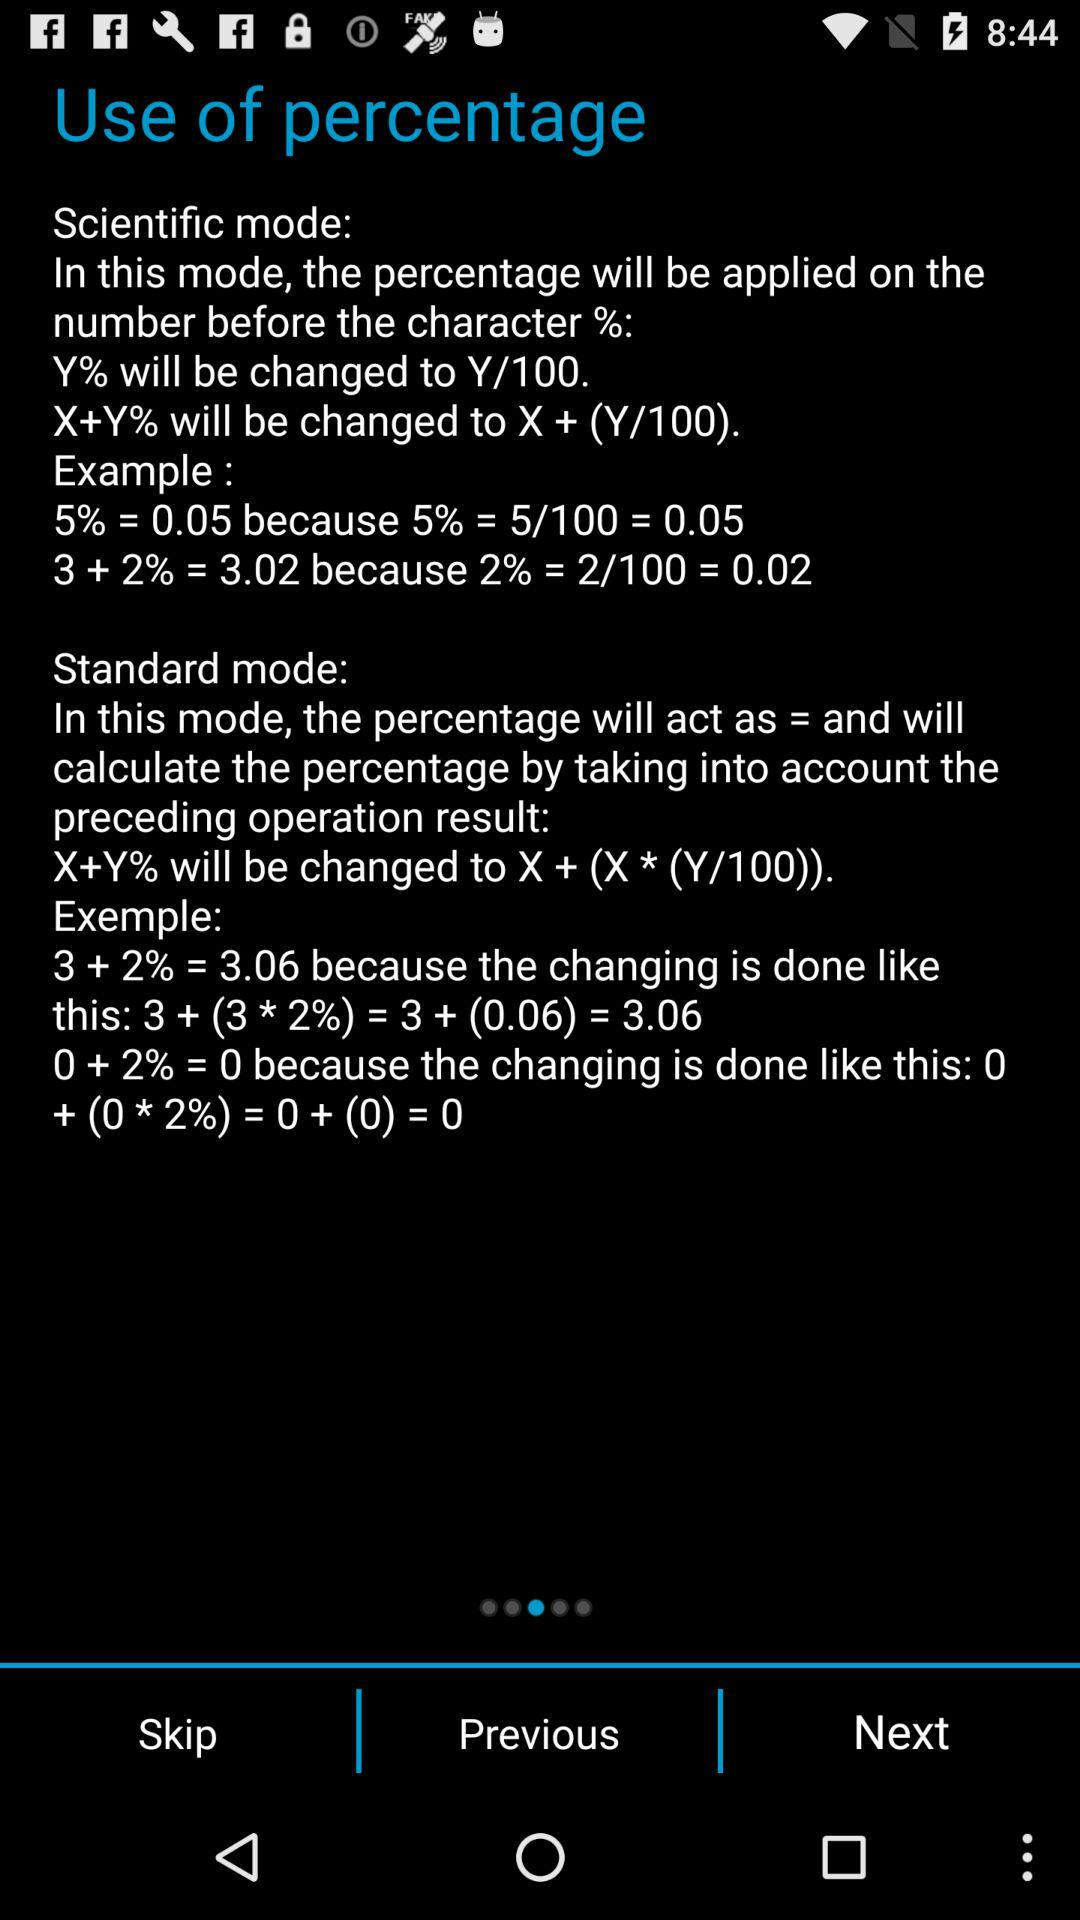How many different modes are there?
Answer the question using a single word or phrase. 2 